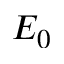Convert formula to latex. <formula><loc_0><loc_0><loc_500><loc_500>E _ { 0 }</formula> 